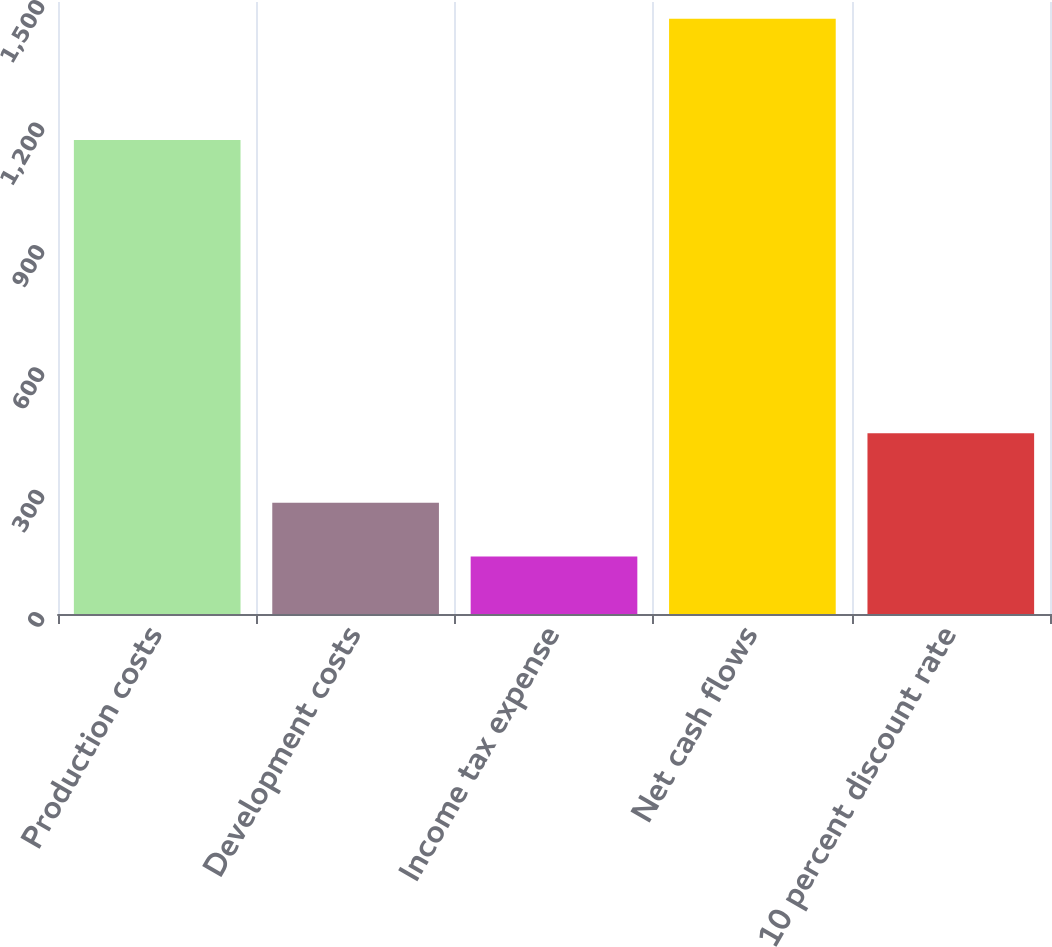Convert chart to OTSL. <chart><loc_0><loc_0><loc_500><loc_500><bar_chart><fcel>Production costs<fcel>Development costs<fcel>Income tax expense<fcel>Net cash flows<fcel>10 percent discount rate<nl><fcel>1162<fcel>272.8<fcel>141<fcel>1459<fcel>443<nl></chart> 